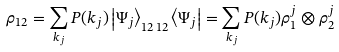<formula> <loc_0><loc_0><loc_500><loc_500>\rho _ { 1 2 } = \sum _ { { k } _ { j } } P ( { k } _ { j } ) \left | \Psi _ { j } \right \rangle _ { 1 2 \, 1 2 } \left \langle \Psi _ { j } \right | = \sum _ { { k } _ { j } } P ( { k } _ { j } ) \rho _ { 1 } ^ { j } \otimes \rho _ { 2 } ^ { j }</formula> 